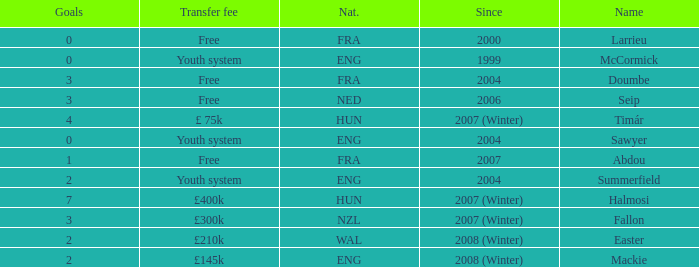What is the nationality of the player with a transfer fee of £400k? HUN. 